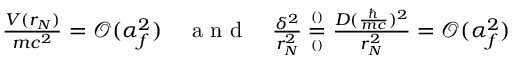<formula> <loc_0><loc_0><loc_500><loc_500>\begin{array} { r } { \frac { V ( r _ { N } ) } { m c ^ { 2 } } = \mathcal { O } ( \alpha _ { f } ^ { 2 } ) \quad a n d \quad \frac { \delta ^ { 2 } } { r _ { N } ^ { 2 } } \overset { ^ { ( ) } } { \underset { ^ { ( ) } } { = } } \frac { D ( \frac { } { m c } ) ^ { 2 } } { r _ { N } ^ { 2 } } = \mathcal { O } ( \alpha _ { f } ^ { 2 } ) } \end{array}</formula> 